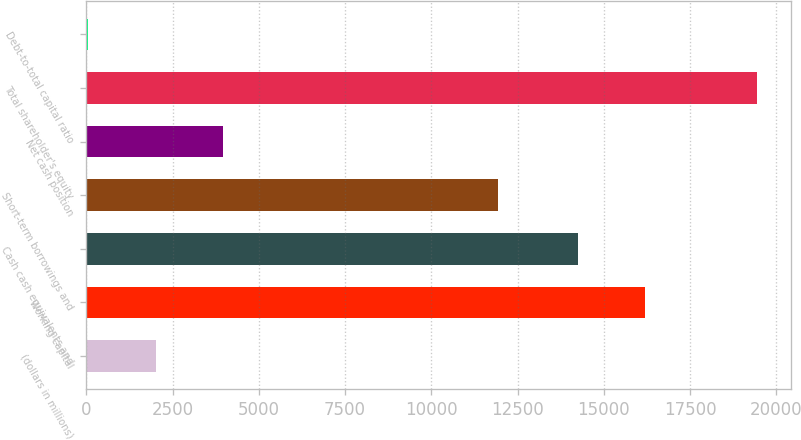Convert chart to OTSL. <chart><loc_0><loc_0><loc_500><loc_500><bar_chart><fcel>(dollars in millions)<fcel>Working capital<fcel>Cash cash equivalents and<fcel>Short-term borrowings and<fcel>Net cash position<fcel>Total shareholder's equity<fcel>Debt-to-total capital ratio<nl><fcel>2014<fcel>16181.5<fcel>14241<fcel>11928<fcel>3954.5<fcel>19443<fcel>38<nl></chart> 